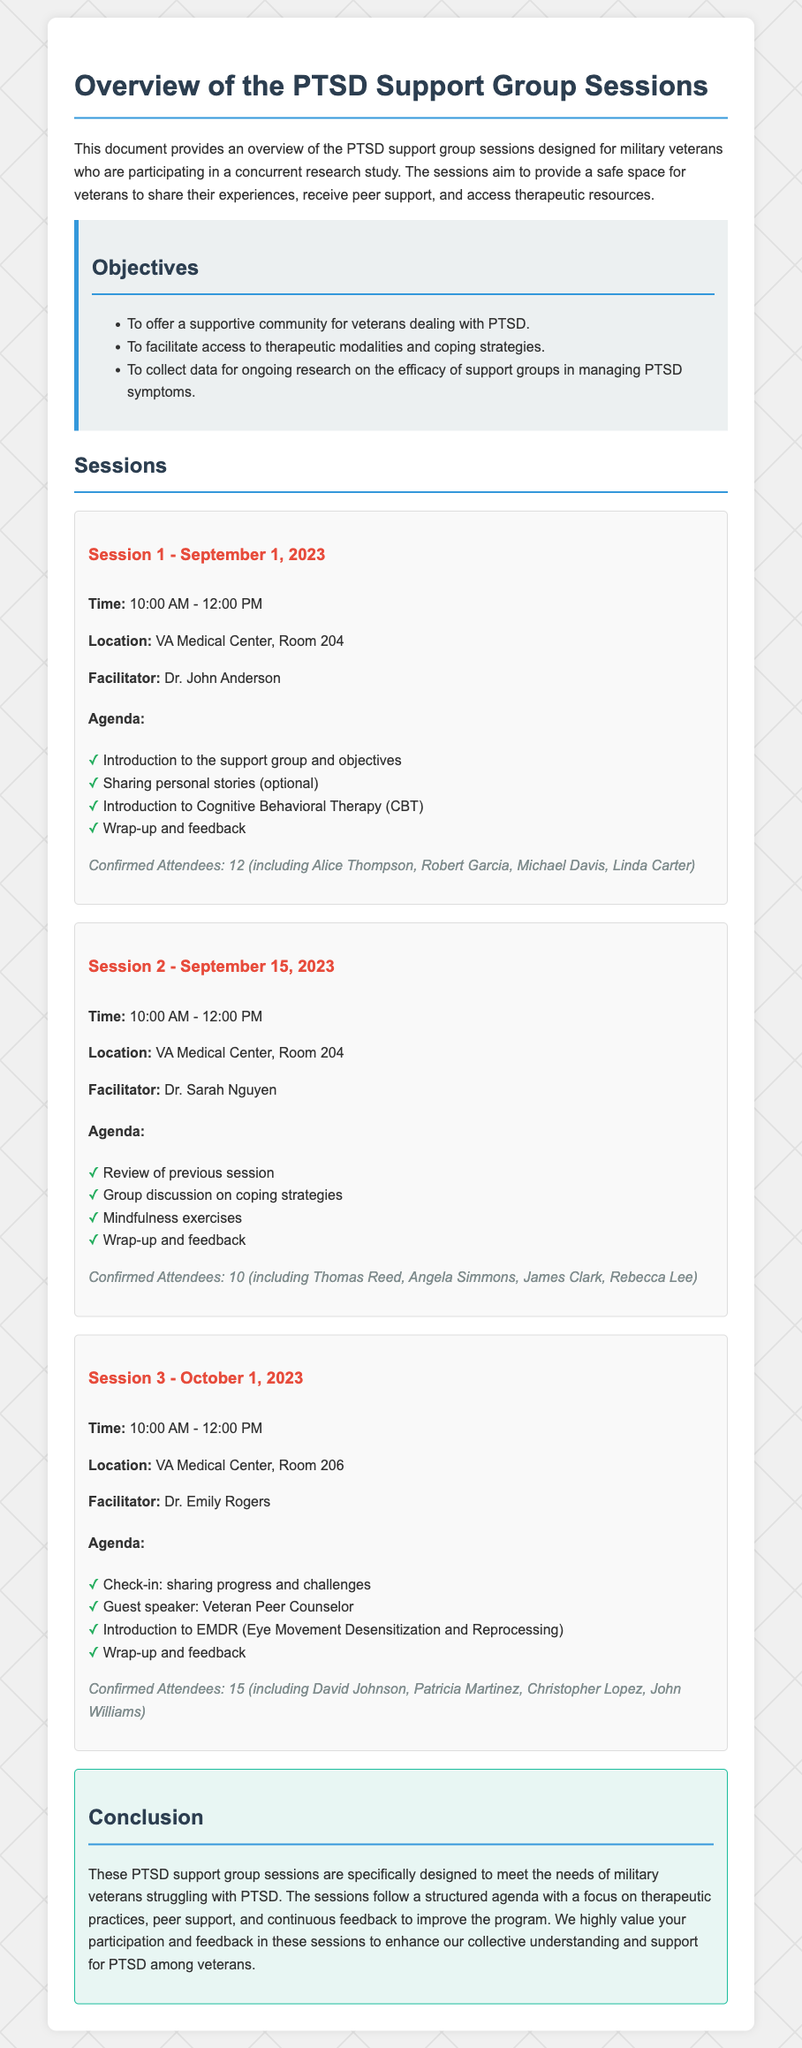What is the date of Session 1? The date of Session 1 is specifically mentioned in the document as September 1, 2023.
Answer: September 1, 2023 Who is the facilitator of Session 2? The facilitator for Session 2 is stated in the document as Dr. Sarah Nguyen.
Answer: Dr. Sarah Nguyen How many attendees were confirmed for Session 3? The number of confirmed attendees for Session 3 is provided in the document, which shows 15 attendees.
Answer: 15 What topic was introduced in Session 1? The introduction topic for Session 1 is mentioned as Cognitive Behavioral Therapy (CBT).
Answer: Cognitive Behavioral Therapy (CBT) What is the location of the sessions? The document specifies that the sessions are held at the VA Medical Center, and further details can be found for each session.
Answer: VA Medical Center What was discussed in Session 2? Session 2 included discussions on coping strategies as per the agenda provided in the document.
Answer: Coping strategies What therapeutic practice is introduced in Session 3? The therapeutic practice introduced in Session 3 is EMDR (Eye Movement Desensitization and Reprocessing).
Answer: EMDR (Eye Movement Desensitization and Reprocessing) How long does each session last? Each session lasts for 2 hours as per the timing stated in the document (10:00 AM - 12:00 PM).
Answer: 2 hours 